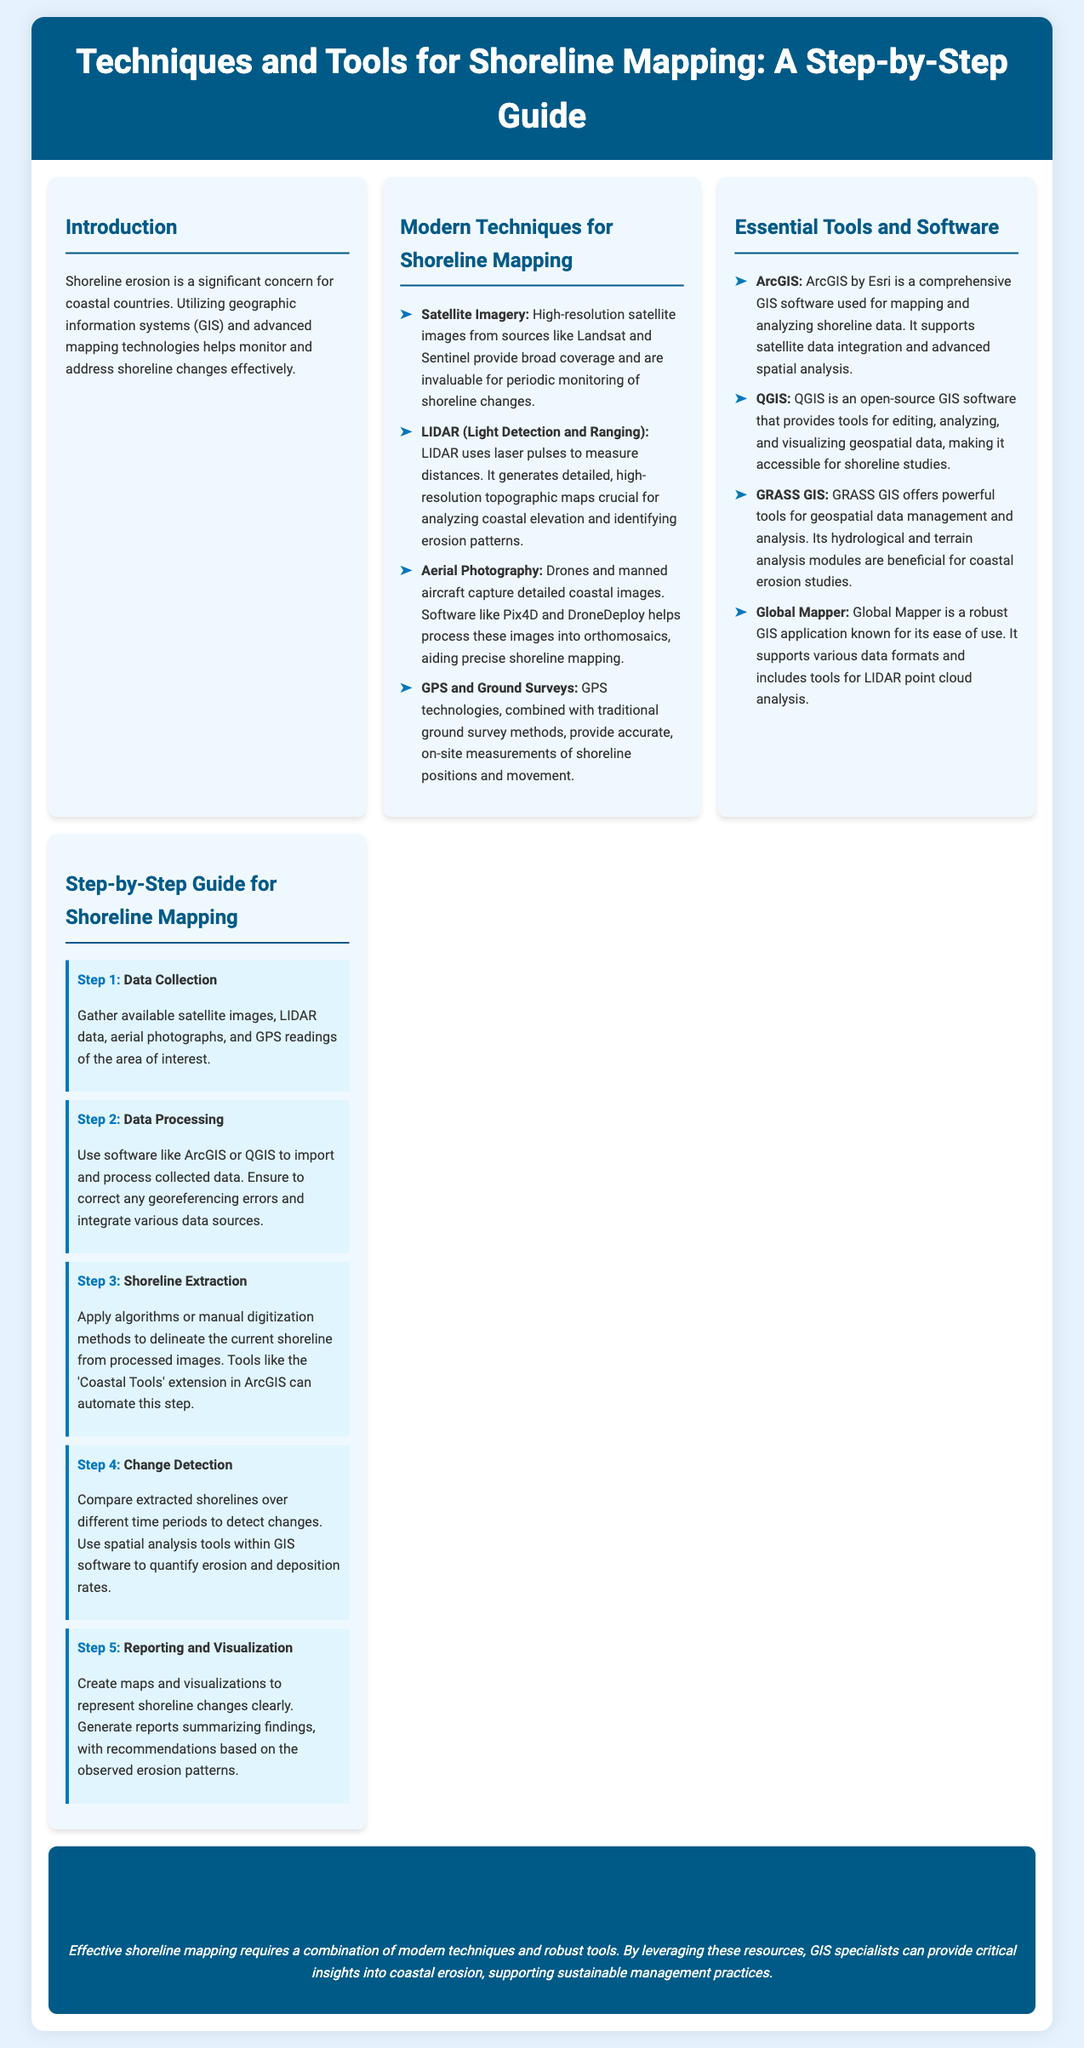What are the four modern techniques for shoreline mapping? The document lists four techniques: Satellite Imagery, LIDAR, Aerial Photography, and GPS and Ground Surveys.
Answer: Satellite Imagery, LIDAR, Aerial Photography, GPS and Ground Surveys Which software is known for being open-source for shoreline studies? The document mentions QGIS as the open-source GIS software suitable for shoreline studies.
Answer: QGIS What is the first step in the shoreline mapping process? The first step in the process according to the document is Data Collection.
Answer: Data Collection How many steps are there in the shoreline mapping guide? The guide outlines five steps for shoreline mapping.
Answer: Five What kind of technologies does LIDAR use to measure distances? The document describes LIDAR as using laser pulses to measure distances.
Answer: Laser pulses Which software supports LIDAR point cloud analysis? The document states that Global Mapper supports LIDAR point cloud analysis.
Answer: Global Mapper What is the main focus of the introduction in the document? The introduction focuses on the significance of shoreline erosion and the use of GIS technologies to monitor it.
Answer: Shoreline erosion What should be created in Step 5 of shoreline mapping? In Step 5, the document emphasizes the creation of maps and visualizations.
Answer: Maps and visualizations What color is used for headings in the document? The headings are formatted in the color #005a87 according to the styling in the document.
Answer: #005a87 